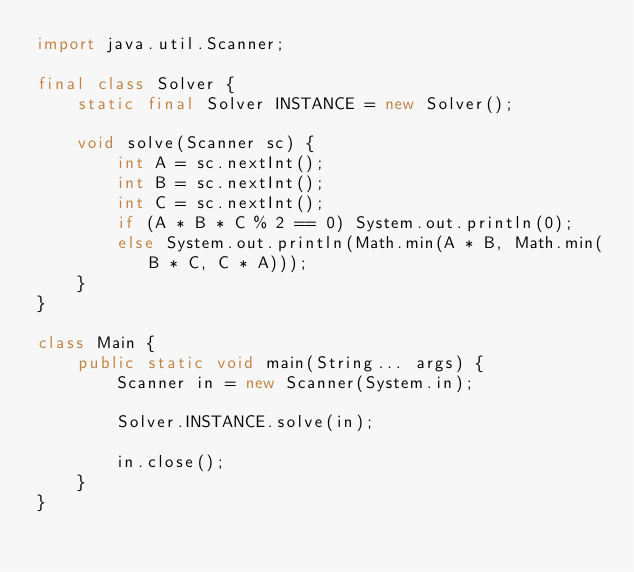<code> <loc_0><loc_0><loc_500><loc_500><_Java_>import java.util.Scanner;

final class Solver {
	static final Solver INSTANCE = new Solver();

	void solve(Scanner sc) {
		int A = sc.nextInt();
		int B = sc.nextInt();
		int C = sc.nextInt();
		if (A * B * C % 2 == 0) System.out.println(0);
		else System.out.println(Math.min(A * B, Math.min(B * C, C * A)));
	}
}

class Main {
	public static void main(String... args) {
		Scanner in = new Scanner(System.in);

		Solver.INSTANCE.solve(in);

		in.close();
	}
}</code> 